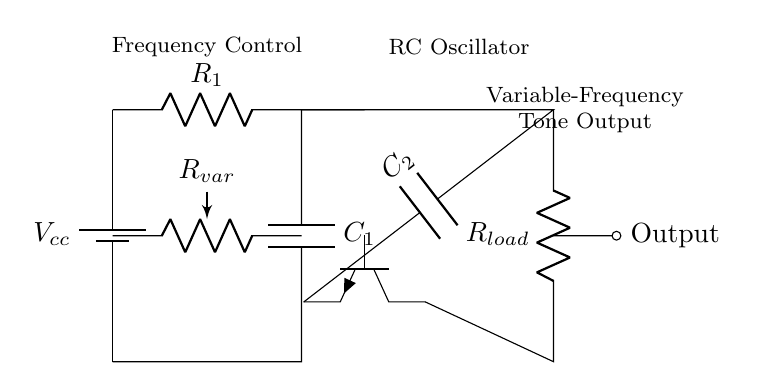What is the main function of the RC oscillator? The main function of the RC oscillator is to generate a variable-frequency tone output, which can be adjusted based on the timing requirements.
Answer: variable-frequency tone output What does the variable resistor control in this circuit? The variable resistor adjusts the resistance, effectively changing the charging and discharging rates of the capacitor, which in turn varies the frequency of the oscillation.
Answer: frequency How many capacitors are used in this circuit? The circuit uses two capacitors: one connecting the RC network and one for feedback to the transistor.
Answer: two What type of transistor is used in this circuit? The circuit utilizes an NPN transistor, which is indicated in the diagram by the specific symbol for NPN components.
Answer: NPN What does the capacitor labeled C1 do? The capacitor C1 is part of the RC timing network, determining the time constant of the circuit along with the resistor R1, influencing the output frequency.
Answer: determines time constant What role does the load resistor play in the circuit? The load resistor R_load is connected to the output of the transistor and functions to limit current and ensure suitable levels for the output signal to drive connected components or devices.
Answer: limits current What happens if the resistance of R_var is decreased? Decreasing the resistance of R_var increases the rate of charge and discharge of C1, which raises the frequency of the output signal produced by the oscillator circuit.
Answer: increases frequency 